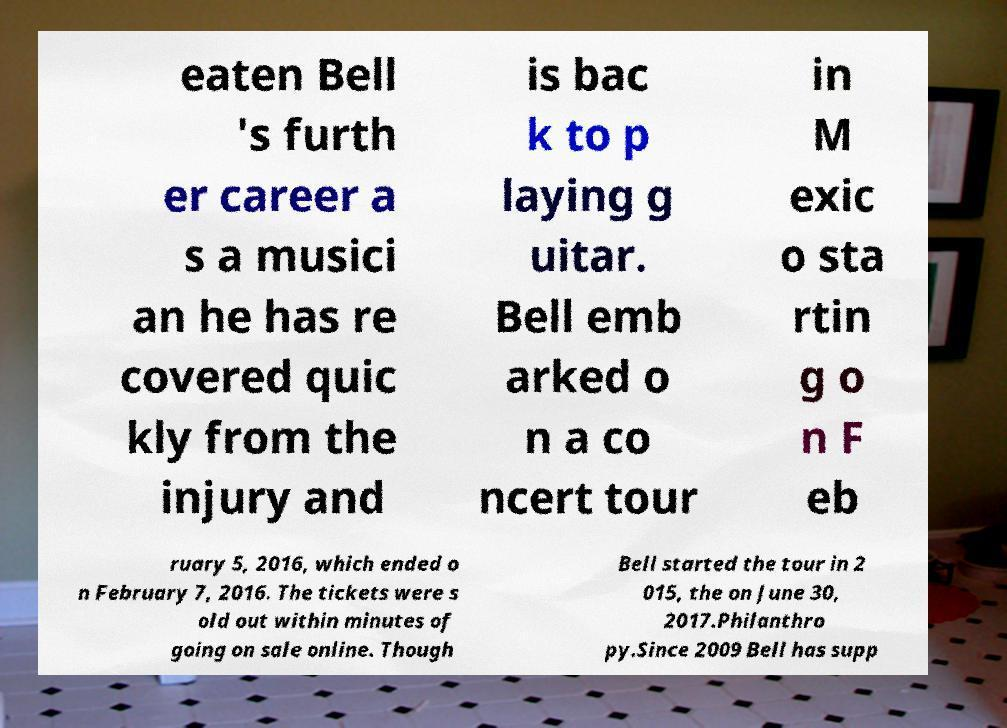Can you accurately transcribe the text from the provided image for me? eaten Bell 's furth er career a s a musici an he has re covered quic kly from the injury and is bac k to p laying g uitar. Bell emb arked o n a co ncert tour in M exic o sta rtin g o n F eb ruary 5, 2016, which ended o n February 7, 2016. The tickets were s old out within minutes of going on sale online. Though Bell started the tour in 2 015, the on June 30, 2017.Philanthro py.Since 2009 Bell has supp 